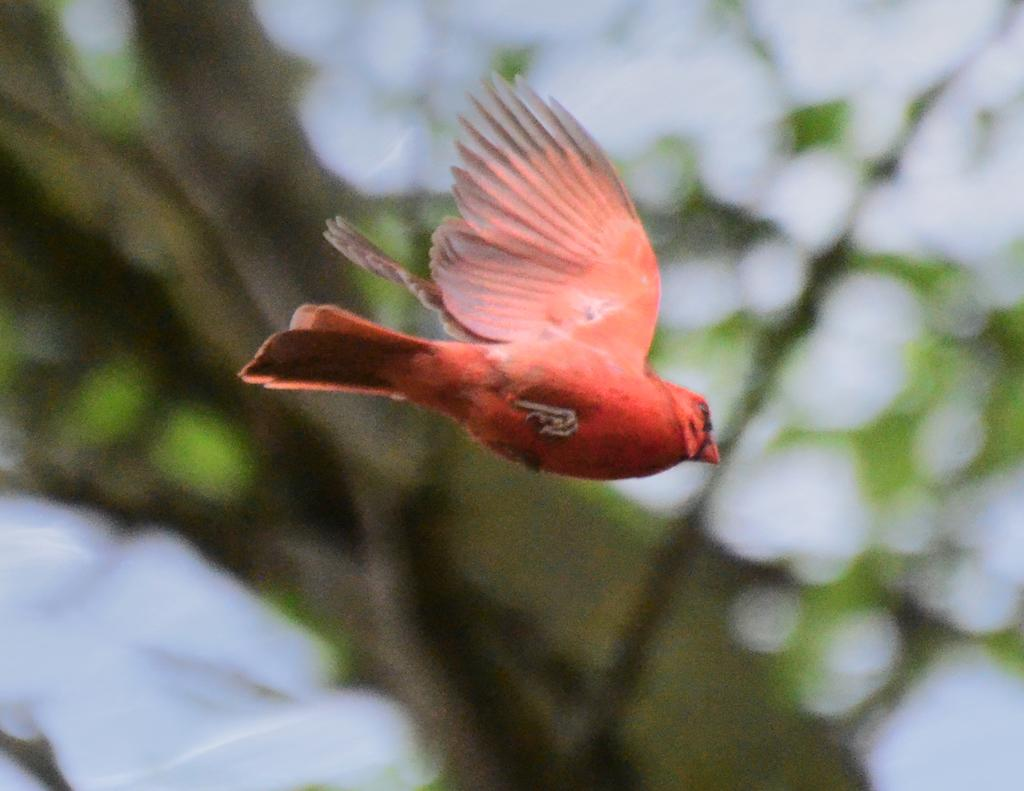What type of animal can be seen in the image? There is a bird in the image. What is the bird doing in the image? The bird is flying in the air. What current is the bird swimming in within the image? The bird is flying in the air, not swimming in a current. 